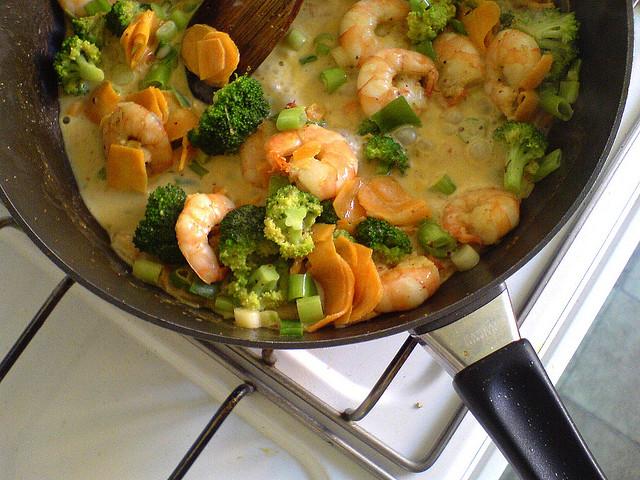Is this a vegan meal?
Quick response, please. No. Name one ingredient in the skillet?
Concise answer only. Shrimp. Is this a healthy meal?
Quick response, please. Yes. 